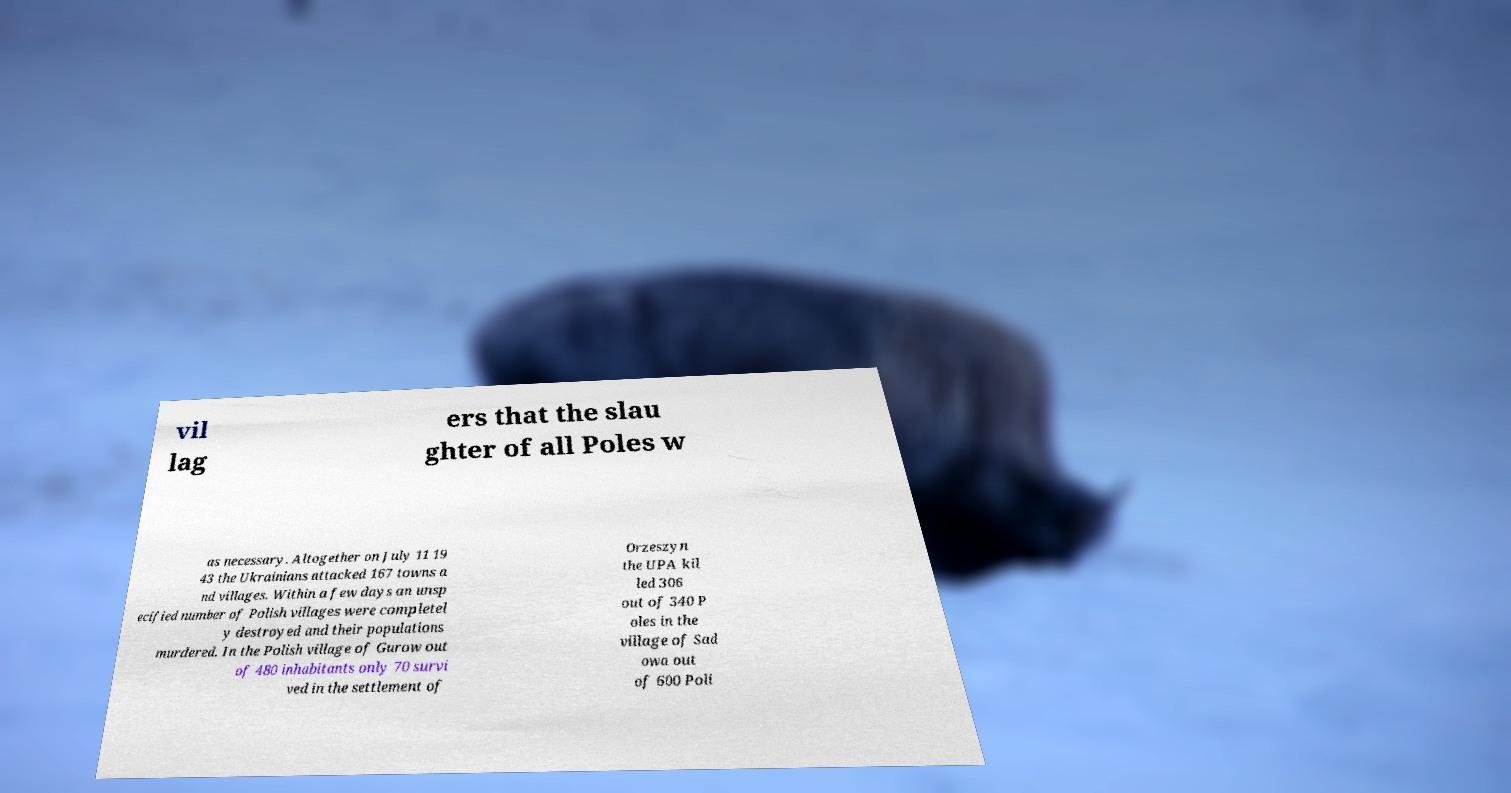What messages or text are displayed in this image? I need them in a readable, typed format. vil lag ers that the slau ghter of all Poles w as necessary. Altogether on July 11 19 43 the Ukrainians attacked 167 towns a nd villages. Within a few days an unsp ecified number of Polish villages were completel y destroyed and their populations murdered. In the Polish village of Gurow out of 480 inhabitants only 70 survi ved in the settlement of Orzeszyn the UPA kil led 306 out of 340 P oles in the village of Sad owa out of 600 Poli 